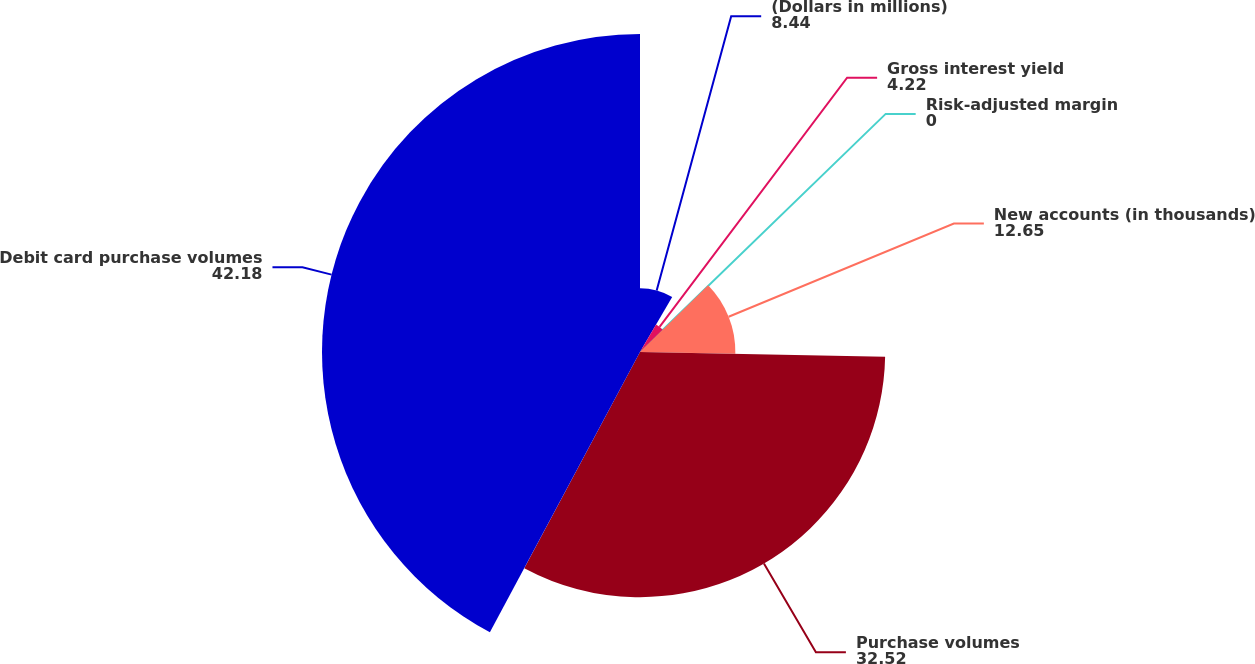Convert chart. <chart><loc_0><loc_0><loc_500><loc_500><pie_chart><fcel>(Dollars in millions)<fcel>Gross interest yield<fcel>Risk-adjusted margin<fcel>New accounts (in thousands)<fcel>Purchase volumes<fcel>Debit card purchase volumes<nl><fcel>8.44%<fcel>4.22%<fcel>0.0%<fcel>12.65%<fcel>32.52%<fcel>42.18%<nl></chart> 